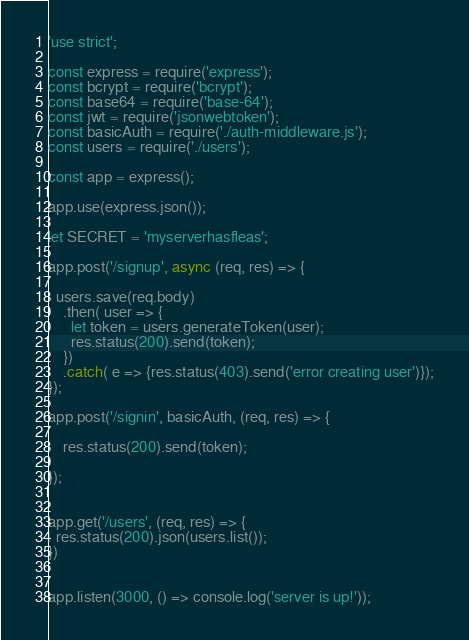Convert code to text. <code><loc_0><loc_0><loc_500><loc_500><_JavaScript_>'use strict';

const express = require('express');
const bcrypt = require('bcrypt');
const base64 = require('base-64');
const jwt = require('jsonwebtoken');
const basicAuth = require('./auth-middleware.js');
const users = require('./users');

const app = express();

app.use(express.json());

let SECRET = 'myserverhasfleas';

app.post('/signup', async (req, res) => {

  users.save(req.body) 
    .then( user => {
      let token = users.generateToken(user);
      res.status(200).send(token);
    })
    .catch( e => {res.status(403).send('error creating user')});
});

app.post('/signin', basicAuth, (req, res) => {

    res.status(200).send(token);

});


app.get('/users', (req, res) => {
  res.status(200).json(users.list());
})


app.listen(3000, () => console.log('server is up!'));

</code> 